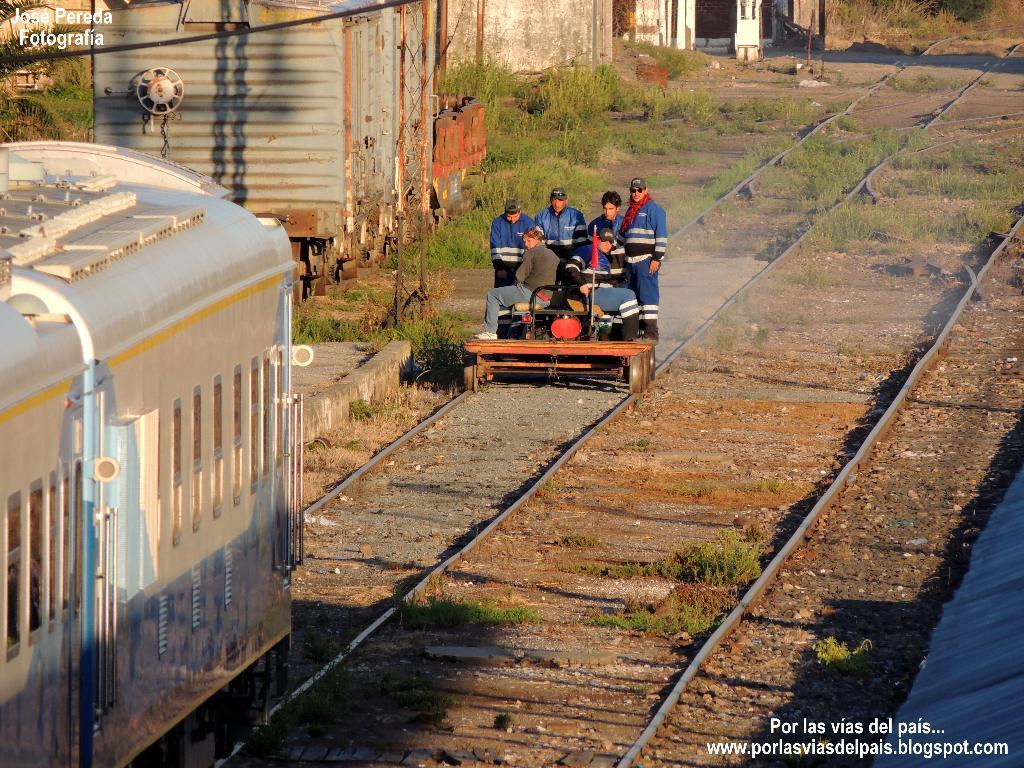What is the vehicle carrying people in the image? There is a train in the image, and people are on it. What type of infrastructure is present in the image? There are rail tracks in the image. What structure can be seen in the image? There is a shed in the image. What material is visible in the image? There are iron rods in the image. What type of vegetation is present in the image? There are plants in the image. What symbol can be seen in the image? There is a flag in the image. What hobbies are the people on the train engaging in during the summer? The provided facts do not mention any hobbies or the season, so we cannot determine what hobbies the people are engaging in or if it is summer. 